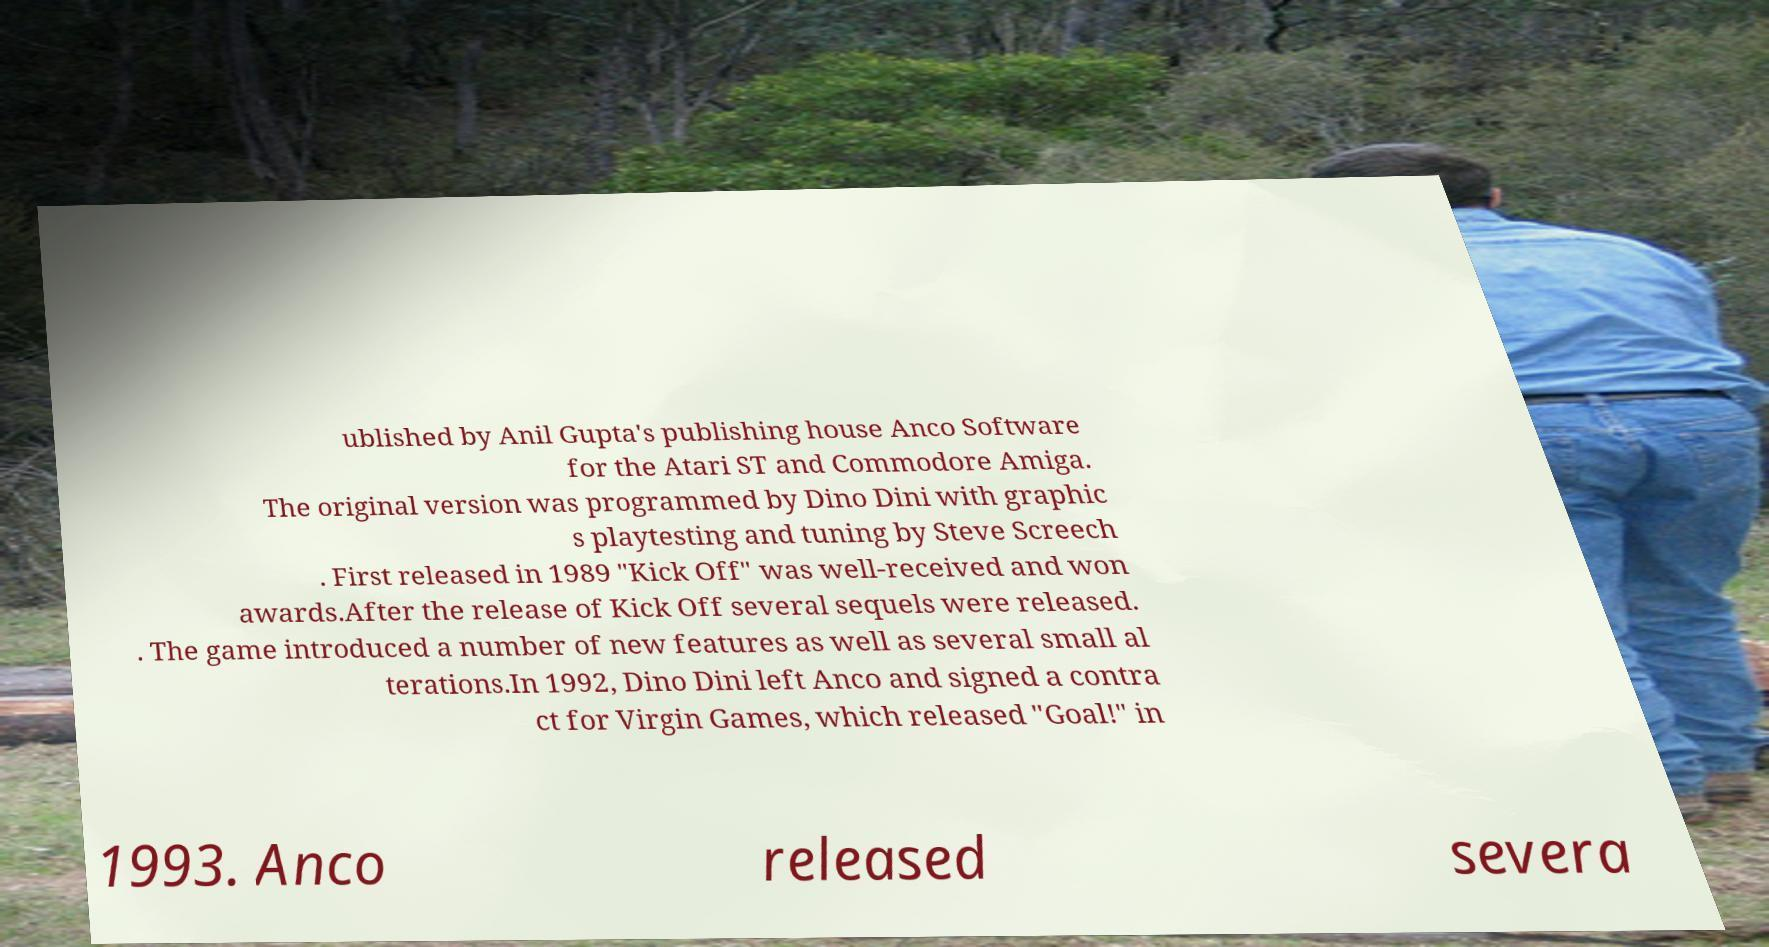Can you accurately transcribe the text from the provided image for me? ublished by Anil Gupta's publishing house Anco Software for the Atari ST and Commodore Amiga. The original version was programmed by Dino Dini with graphic s playtesting and tuning by Steve Screech . First released in 1989 "Kick Off" was well-received and won awards.After the release of Kick Off several sequels were released. . The game introduced a number of new features as well as several small al terations.In 1992, Dino Dini left Anco and signed a contra ct for Virgin Games, which released "Goal!" in 1993. Anco released severa 